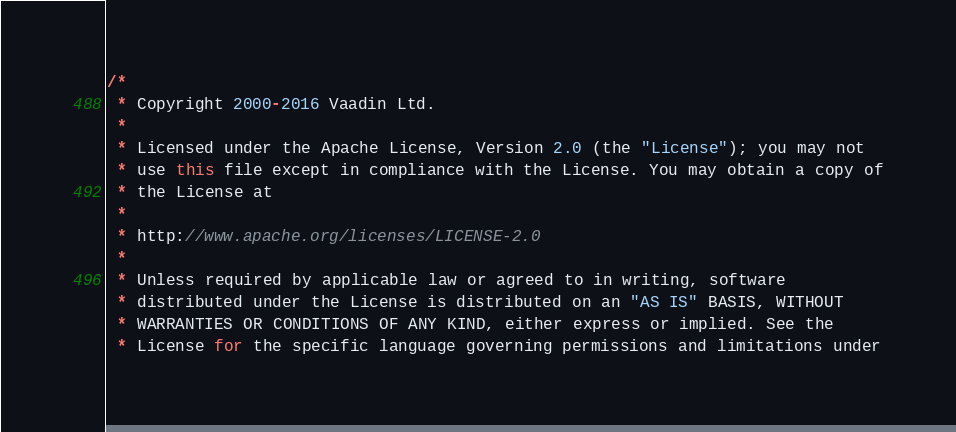Convert code to text. <code><loc_0><loc_0><loc_500><loc_500><_Java_>/*
 * Copyright 2000-2016 Vaadin Ltd.
 *
 * Licensed under the Apache License, Version 2.0 (the "License"); you may not
 * use this file except in compliance with the License. You may obtain a copy of
 * the License at
 *
 * http://www.apache.org/licenses/LICENSE-2.0
 *
 * Unless required by applicable law or agreed to in writing, software
 * distributed under the License is distributed on an "AS IS" BASIS, WITHOUT
 * WARRANTIES OR CONDITIONS OF ANY KIND, either express or implied. See the
 * License for the specific language governing permissions and limitations under</code> 